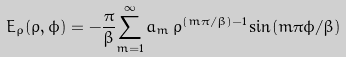<formula> <loc_0><loc_0><loc_500><loc_500>E _ { \rho } ( \rho , \phi ) = - \frac { \pi } { \beta } { \sum _ { m = 1 } ^ { \infty } } \, a _ { m } \, \rho ^ { ( m \pi / \beta ) - 1 } \sin ( m \pi \phi / \beta )</formula> 